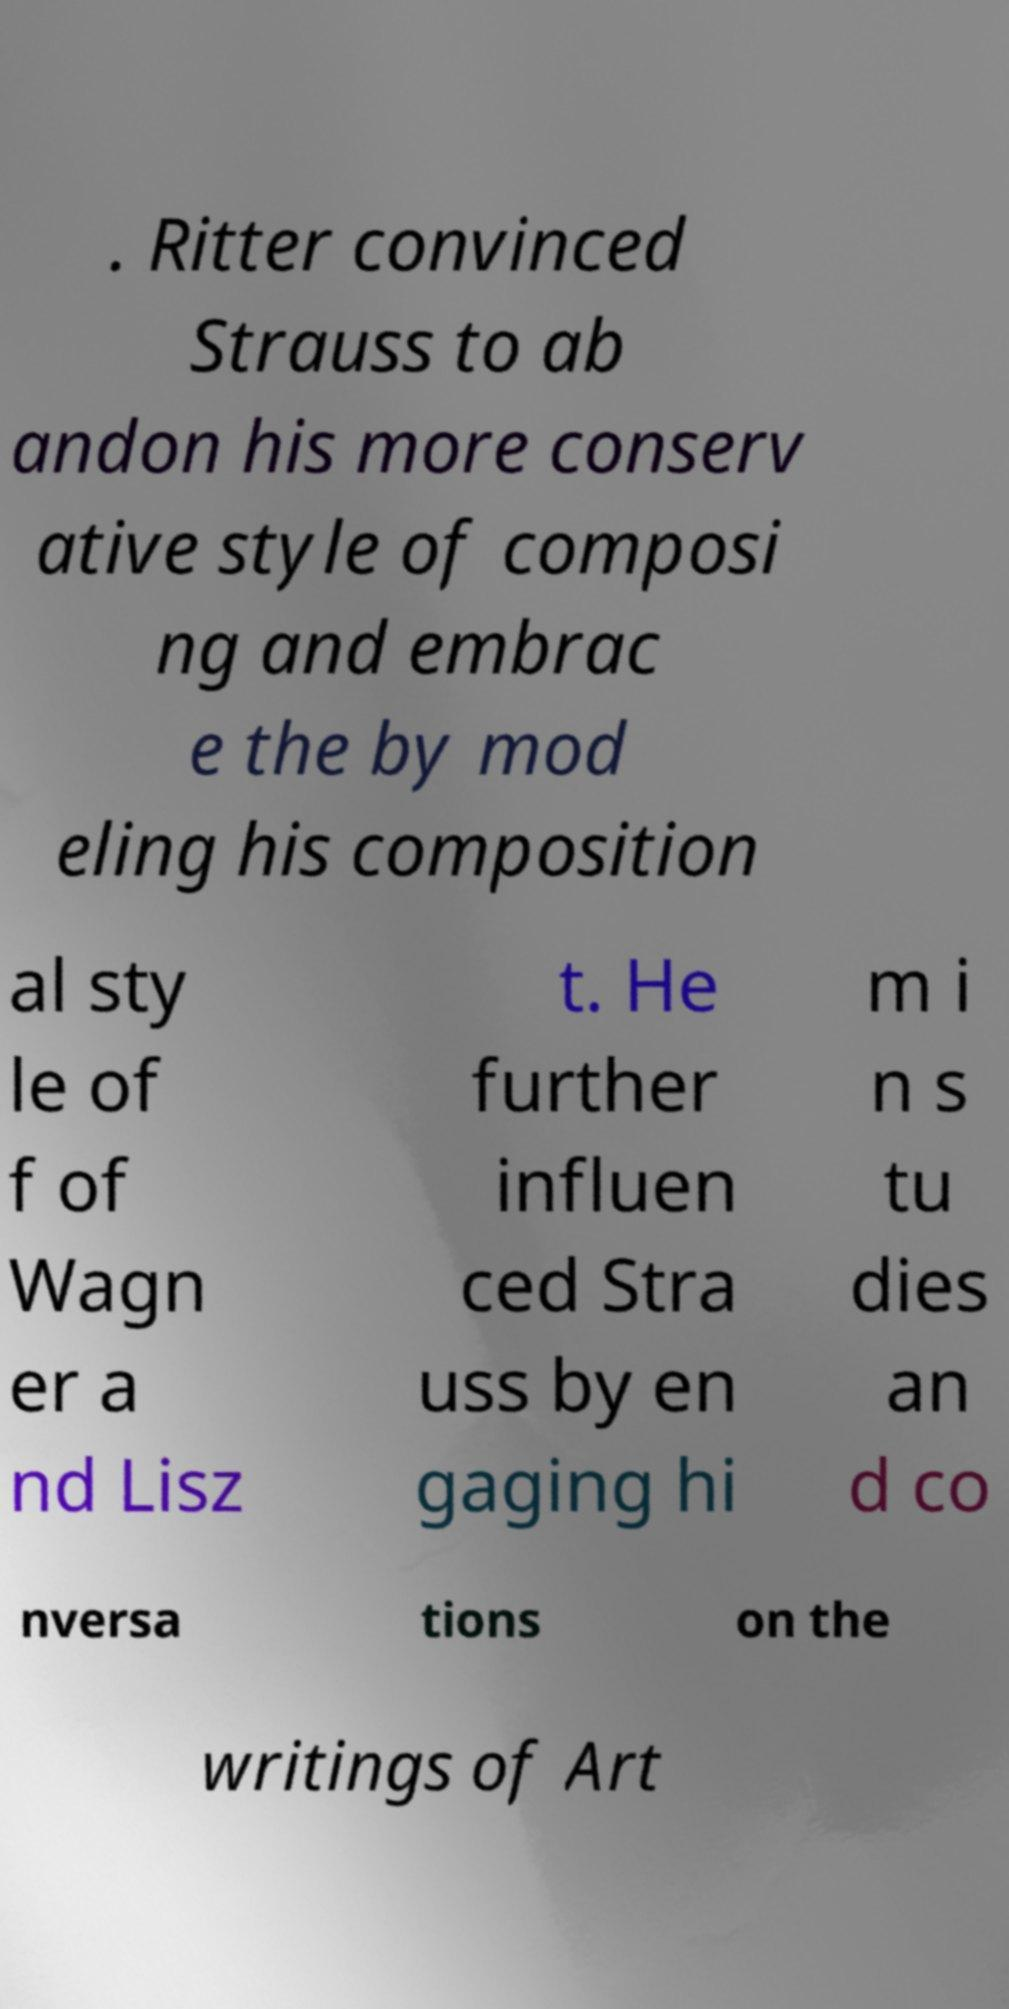Please read and relay the text visible in this image. What does it say? . Ritter convinced Strauss to ab andon his more conserv ative style of composi ng and embrac e the by mod eling his composition al sty le of f of Wagn er a nd Lisz t. He further influen ced Stra uss by en gaging hi m i n s tu dies an d co nversa tions on the writings of Art 